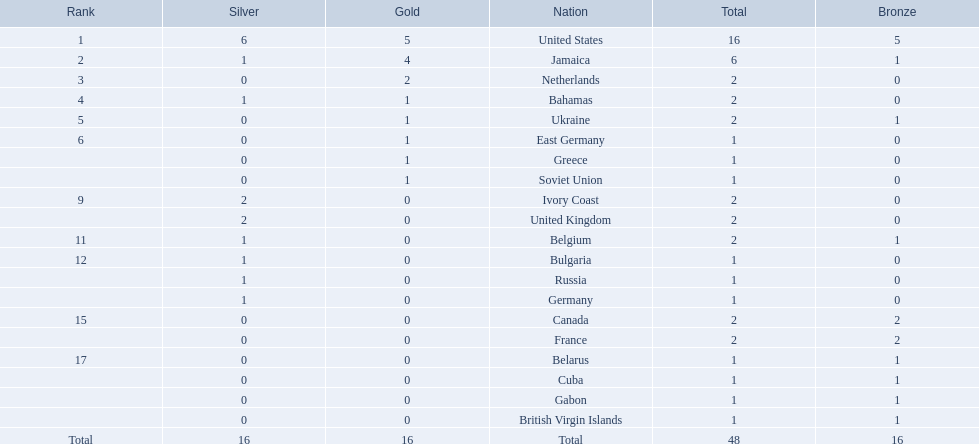Which countries participated? United States, Jamaica, Netherlands, Bahamas, Ukraine, East Germany, Greece, Soviet Union, Ivory Coast, United Kingdom, Belgium, Bulgaria, Russia, Germany, Canada, France, Belarus, Cuba, Gabon, British Virgin Islands. How many gold medals were won by each? 5, 4, 2, 1, 1, 1, 1, 1, 0, 0, 0, 0, 0, 0, 0, 0, 0, 0, 0, 0. Give me the full table as a dictionary. {'header': ['Rank', 'Silver', 'Gold', 'Nation', 'Total', 'Bronze'], 'rows': [['1', '6', '5', 'United States', '16', '5'], ['2', '1', '4', 'Jamaica', '6', '1'], ['3', '0', '2', 'Netherlands', '2', '0'], ['4', '1', '1', 'Bahamas', '2', '0'], ['5', '0', '1', 'Ukraine', '2', '1'], ['6', '0', '1', 'East Germany', '1', '0'], ['', '0', '1', 'Greece', '1', '0'], ['', '0', '1', 'Soviet Union', '1', '0'], ['9', '2', '0', 'Ivory Coast', '2', '0'], ['', '2', '0', 'United Kingdom', '2', '0'], ['11', '1', '0', 'Belgium', '2', '1'], ['12', '1', '0', 'Bulgaria', '1', '0'], ['', '1', '0', 'Russia', '1', '0'], ['', '1', '0', 'Germany', '1', '0'], ['15', '0', '0', 'Canada', '2', '2'], ['', '0', '0', 'France', '2', '2'], ['17', '0', '0', 'Belarus', '1', '1'], ['', '0', '0', 'Cuba', '1', '1'], ['', '0', '0', 'Gabon', '1', '1'], ['', '0', '0', 'British Virgin Islands', '1', '1'], ['Total', '16', '16', 'Total', '48', '16']]} And which country won the most? United States. 